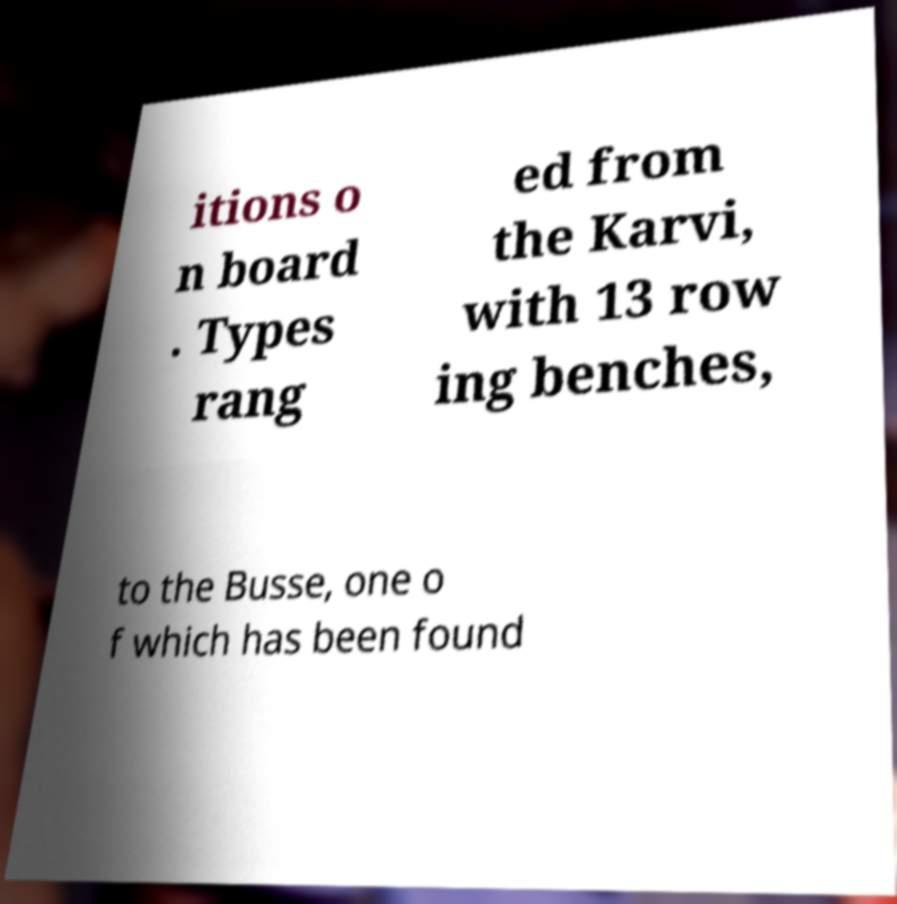Please read and relay the text visible in this image. What does it say? itions o n board . Types rang ed from the Karvi, with 13 row ing benches, to the Busse, one o f which has been found 